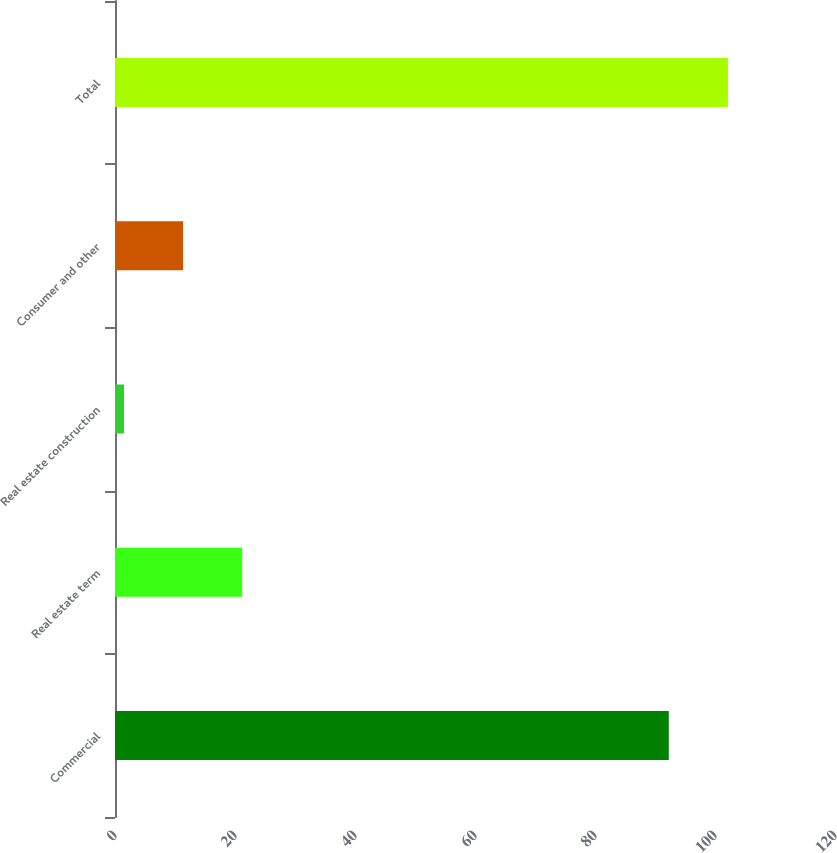<chart> <loc_0><loc_0><loc_500><loc_500><bar_chart><fcel>Commercial<fcel>Real estate term<fcel>Real estate construction<fcel>Consumer and other<fcel>Total<nl><fcel>92.3<fcel>21.2<fcel>1.5<fcel>11.35<fcel>102.15<nl></chart> 